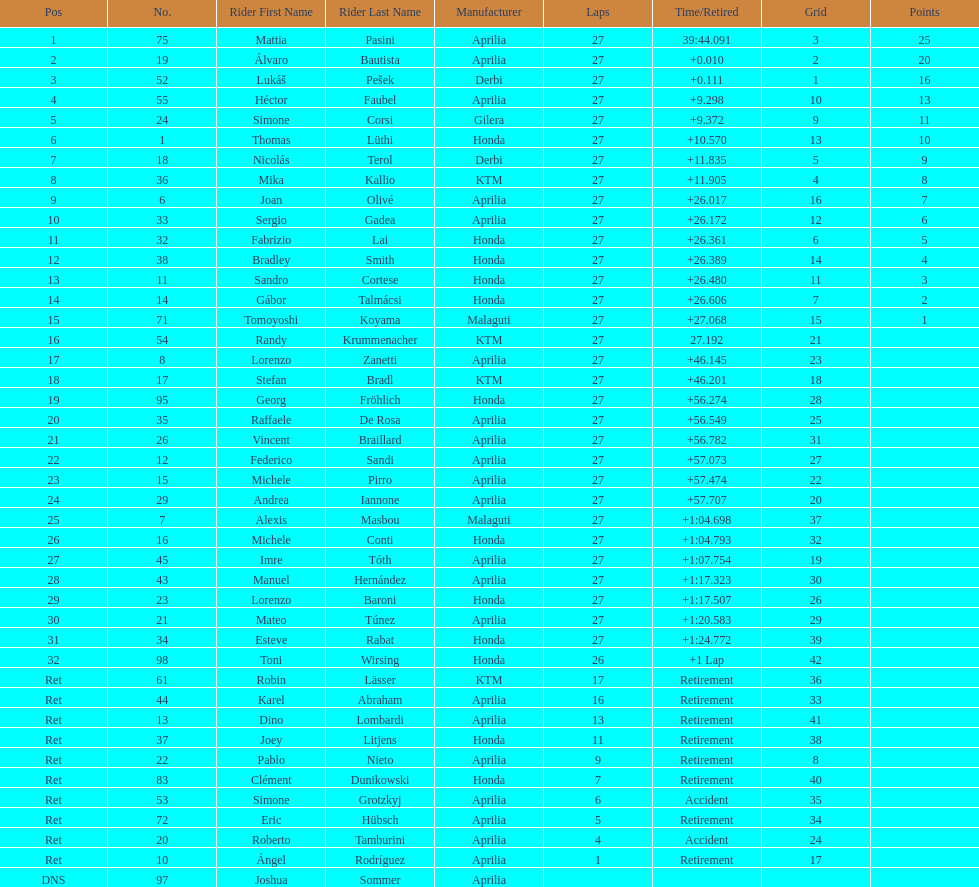Parse the full table. {'header': ['Pos', 'No.', 'Rider First Name', 'Rider Last Name', 'Manufacturer', 'Laps', 'Time/Retired', 'Grid', 'Points'], 'rows': [['1', '75', 'Mattia', 'Pasini', 'Aprilia', '27', '39:44.091', '3', '25'], ['2', '19', 'Álvaro', 'Bautista', 'Aprilia', '27', '+0.010', '2', '20'], ['3', '52', 'Lukáš', 'Pešek', 'Derbi', '27', '+0.111', '1', '16'], ['4', '55', 'Héctor', 'Faubel', 'Aprilia', '27', '+9.298', '10', '13'], ['5', '24', 'Simone', 'Corsi', 'Gilera', '27', '+9.372', '9', '11'], ['6', '1', 'Thomas', 'Lüthi', 'Honda', '27', '+10.570', '13', '10'], ['7', '18', 'Nicolás', 'Terol', 'Derbi', '27', '+11.835', '5', '9'], ['8', '36', 'Mika', 'Kallio', 'KTM', '27', '+11.905', '4', '8'], ['9', '6', 'Joan', 'Olivé', 'Aprilia', '27', '+26.017', '16', '7'], ['10', '33', 'Sergio', 'Gadea', 'Aprilia', '27', '+26.172', '12', '6'], ['11', '32', 'Fabrizio', 'Lai', 'Honda', '27', '+26.361', '6', '5'], ['12', '38', 'Bradley', 'Smith', 'Honda', '27', '+26.389', '14', '4'], ['13', '11', 'Sandro', 'Cortese', 'Honda', '27', '+26.480', '11', '3'], ['14', '14', 'Gábor', 'Talmácsi', 'Honda', '27', '+26.606', '7', '2'], ['15', '71', 'Tomoyoshi', 'Koyama', 'Malaguti', '27', '+27.068', '15', '1'], ['16', '54', 'Randy', 'Krummenacher', 'KTM', '27', '27.192', '21', ''], ['17', '8', 'Lorenzo', 'Zanetti', 'Aprilia', '27', '+46.145', '23', ''], ['18', '17', 'Stefan', 'Bradl', 'KTM', '27', '+46.201', '18', ''], ['19', '95', 'Georg', 'Fröhlich', 'Honda', '27', '+56.274', '28', ''], ['20', '35', 'Raffaele', 'De Rosa', 'Aprilia', '27', '+56.549', '25', ''], ['21', '26', 'Vincent', 'Braillard', 'Aprilia', '27', '+56.782', '31', ''], ['22', '12', 'Federico', 'Sandi', 'Aprilia', '27', '+57.073', '27', ''], ['23', '15', 'Michele', 'Pirro', 'Aprilia', '27', '+57.474', '22', ''], ['24', '29', 'Andrea', 'Iannone', 'Aprilia', '27', '+57.707', '20', ''], ['25', '7', 'Alexis', 'Masbou', 'Malaguti', '27', '+1:04.698', '37', ''], ['26', '16', 'Michele', 'Conti', 'Honda', '27', '+1:04.793', '32', ''], ['27', '45', 'Imre', 'Tóth', 'Aprilia', '27', '+1:07.754', '19', ''], ['28', '43', 'Manuel', 'Hernández', 'Aprilia', '27', '+1:17.323', '30', ''], ['29', '23', 'Lorenzo', 'Baroni', 'Honda', '27', '+1:17.507', '26', ''], ['30', '21', 'Mateo', 'Túnez', 'Aprilia', '27', '+1:20.583', '29', ''], ['31', '34', 'Esteve', 'Rabat', 'Honda', '27', '+1:24.772', '39', ''], ['32', '98', 'Toni', 'Wirsing', 'Honda', '26', '+1 Lap', '42', ''], ['Ret', '61', 'Robin', 'Lässer', 'KTM', '17', 'Retirement', '36', ''], ['Ret', '44', 'Karel', 'Abraham', 'Aprilia', '16', 'Retirement', '33', ''], ['Ret', '13', 'Dino', 'Lombardi', 'Aprilia', '13', 'Retirement', '41', ''], ['Ret', '37', 'Joey', 'Litjens', 'Honda', '11', 'Retirement', '38', ''], ['Ret', '22', 'Pablo', 'Nieto', 'Aprilia', '9', 'Retirement', '8', ''], ['Ret', '83', 'Clément', 'Dunikowski', 'Honda', '7', 'Retirement', '40', ''], ['Ret', '53', 'Simone', 'Grotzkyj', 'Aprilia', '6', 'Accident', '35', ''], ['Ret', '72', 'Eric', 'Hübsch', 'Aprilia', '5', 'Retirement', '34', ''], ['Ret', '20', 'Roberto', 'Tamburini', 'Aprilia', '4', 'Accident', '24', ''], ['Ret', '10', 'Ángel', 'Rodríguez', 'Aprilia', '1', 'Retirement', '17', ''], ['DNS', '97', 'Joshua', 'Sommer', 'Aprilia', '', '', '', '']]} Name a racer that had at least 20 points. Mattia Pasini. 